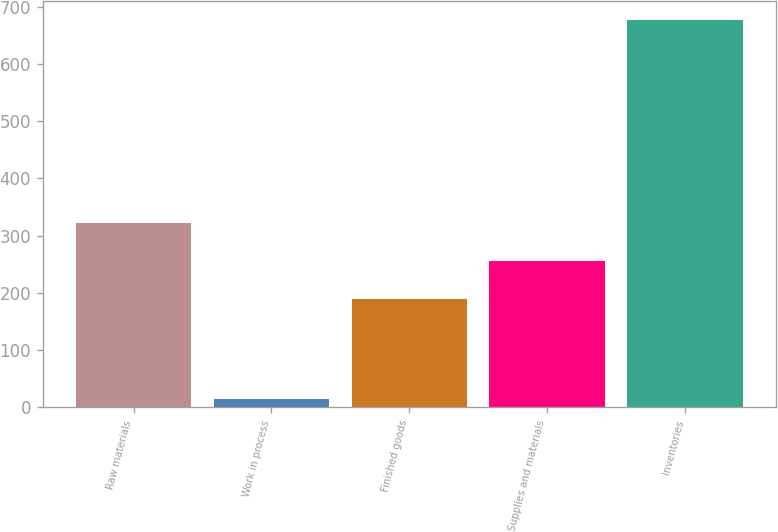Convert chart to OTSL. <chart><loc_0><loc_0><loc_500><loc_500><bar_chart><fcel>Raw materials<fcel>Work in process<fcel>Finished goods<fcel>Supplies and materials<fcel>Inventories<nl><fcel>322.22<fcel>14.2<fcel>189.7<fcel>255.96<fcel>676.8<nl></chart> 